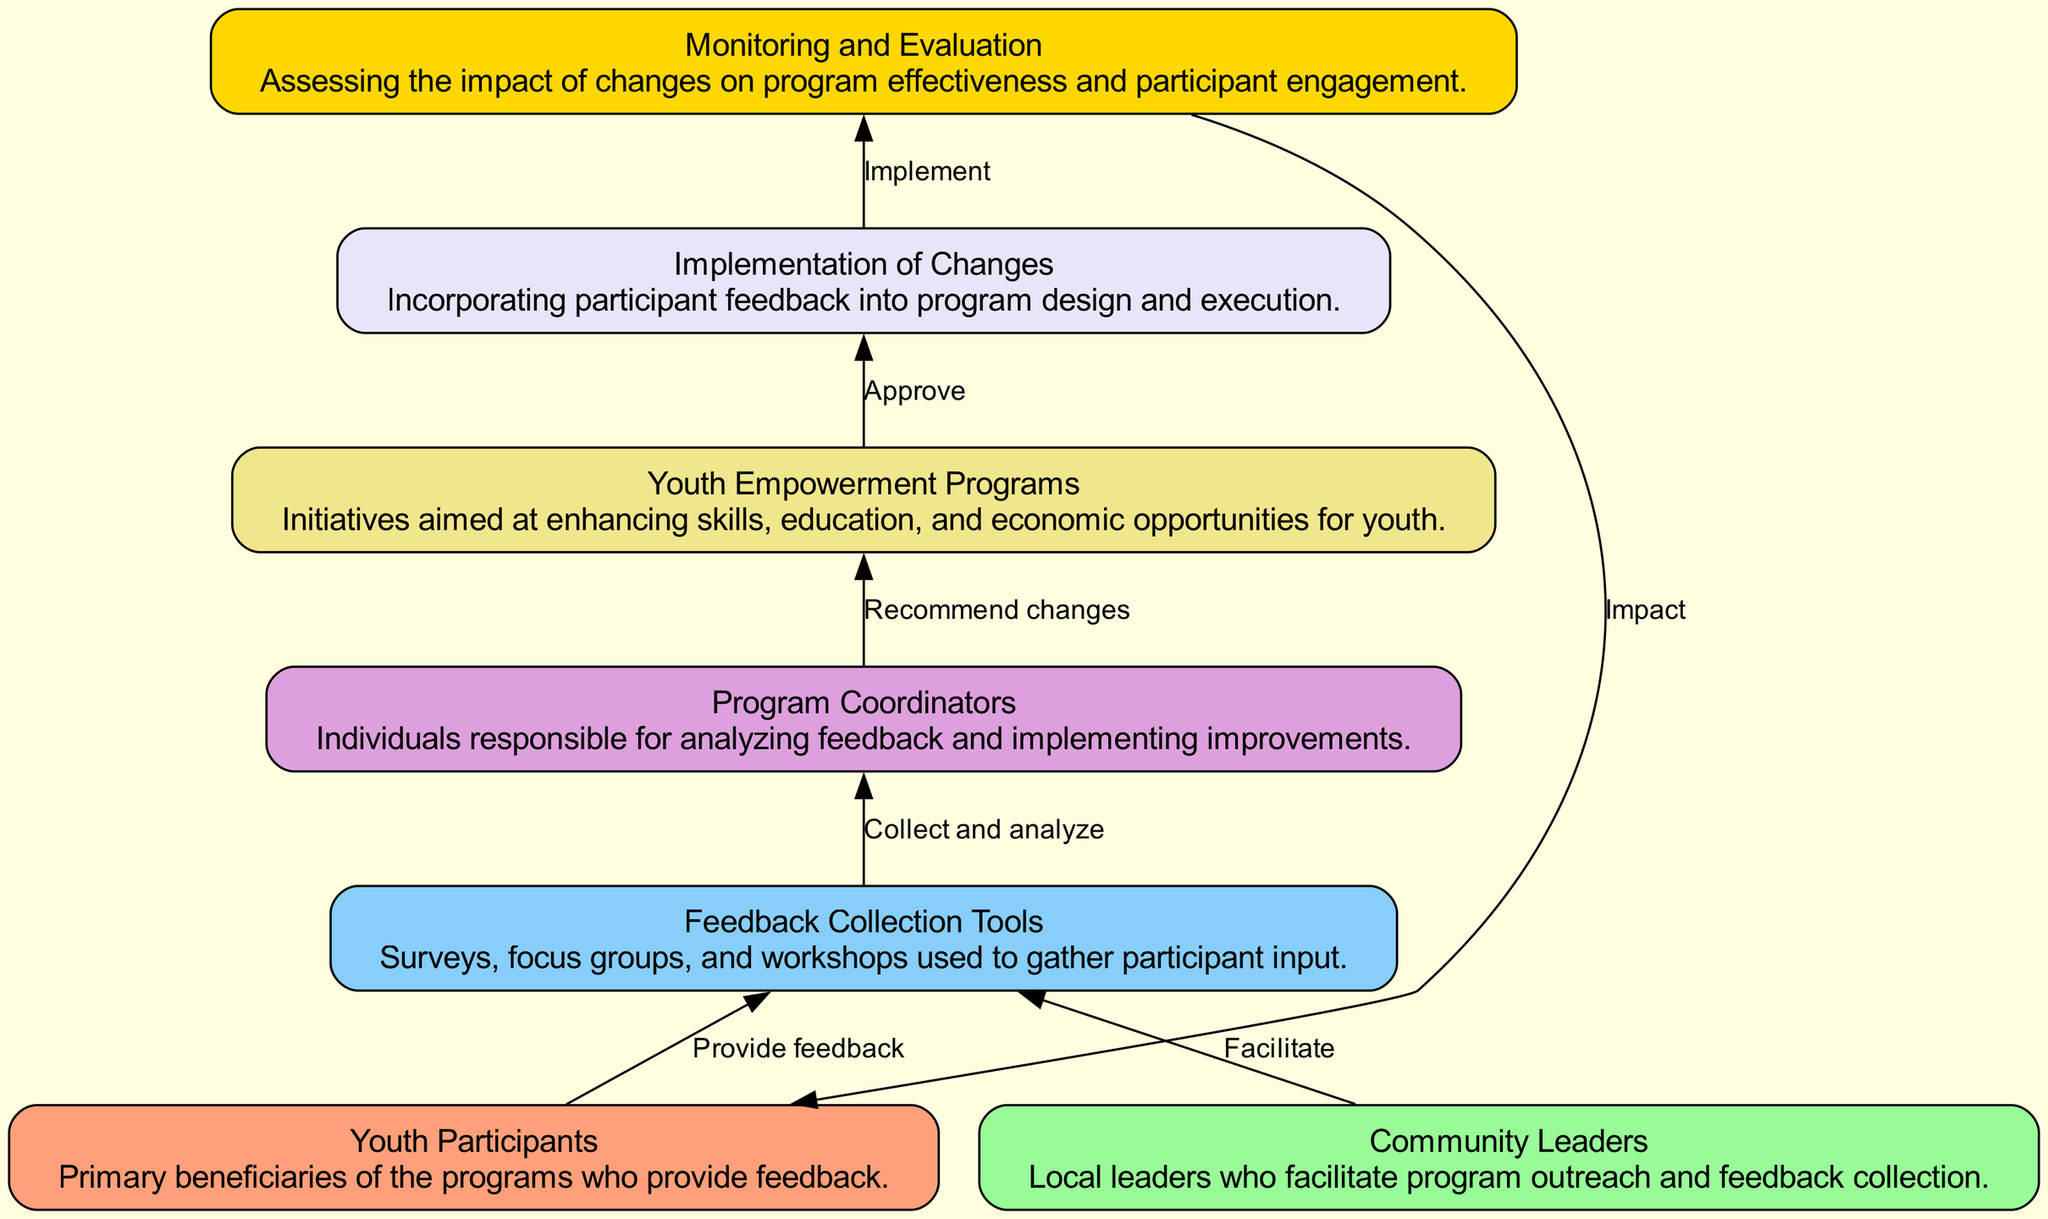What is the primary beneficiary of the programs? The diagram identifies "Youth Participants" as the primary beneficiaries, which is explicitly stated within the node's description.
Answer: Youth Participants How many nodes are there in the diagram? By counting the distinct elements introduced in the elements list (1 through 7), we conclude there are a total of 7 nodes.
Answer: 7 What do "Community Leaders" facilitate? The diagram indicates that "Community Leaders" facilitate the "Feedback Collection Tools," as shown by the edge connecting these two nodes.
Answer: Feedback Collection Tools What is the role of "Program Coordinators"? According to the diagram, "Program Coordinators" are responsible for collecting and analyzing feedback, which is outlined in their node description.
Answer: Analyzing feedback What happens after "Implementation of Changes"? The diagram shows that after implementing changes, the next step involves "Monitoring and Evaluation," indicating that the impact of the changes is assessed thereafter.
Answer: Monitoring and Evaluation Which node collects feedback? The node called "Feedback Collection Tools" is specifically designated for gathering input from participants, as per the description within the diagram.
Answer: Feedback Collection Tools What edge connects "Youth Participants" and "Implementation of Changes"? The edge labeled "Impact" connects "Youth Participants" to "Implementation of Changes," showing the feedback flow from participants to the changes implemented.
Answer: Impact From which node does "Program Coordinators" receive feedback? "Program Coordinators" receive feedback from the "Feedback Collection Tools," as indicated by the directed edge that leads into the "Program Coordinators" node.
Answer: Feedback Collection Tools What do participants provide to the feedback collection tools? Participants provide "feedback," which is directly stated on the edge connecting "Youth Participants" to "Feedback Collection Tools."
Answer: Feedback 